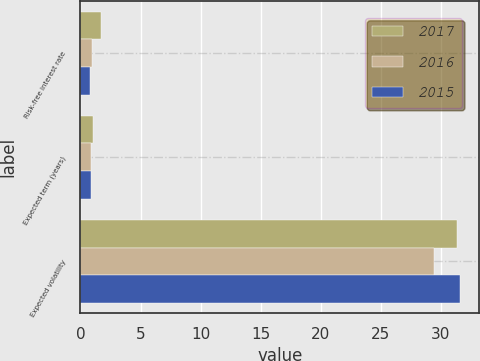Convert chart. <chart><loc_0><loc_0><loc_500><loc_500><stacked_bar_chart><ecel><fcel>Risk-free interest rate<fcel>Expected term (years)<fcel>Expected volatility<nl><fcel>2017<fcel>1.74<fcel>1<fcel>31.37<nl><fcel>2016<fcel>0.95<fcel>0.9<fcel>29.46<nl><fcel>2015<fcel>0.83<fcel>0.9<fcel>31.59<nl></chart> 